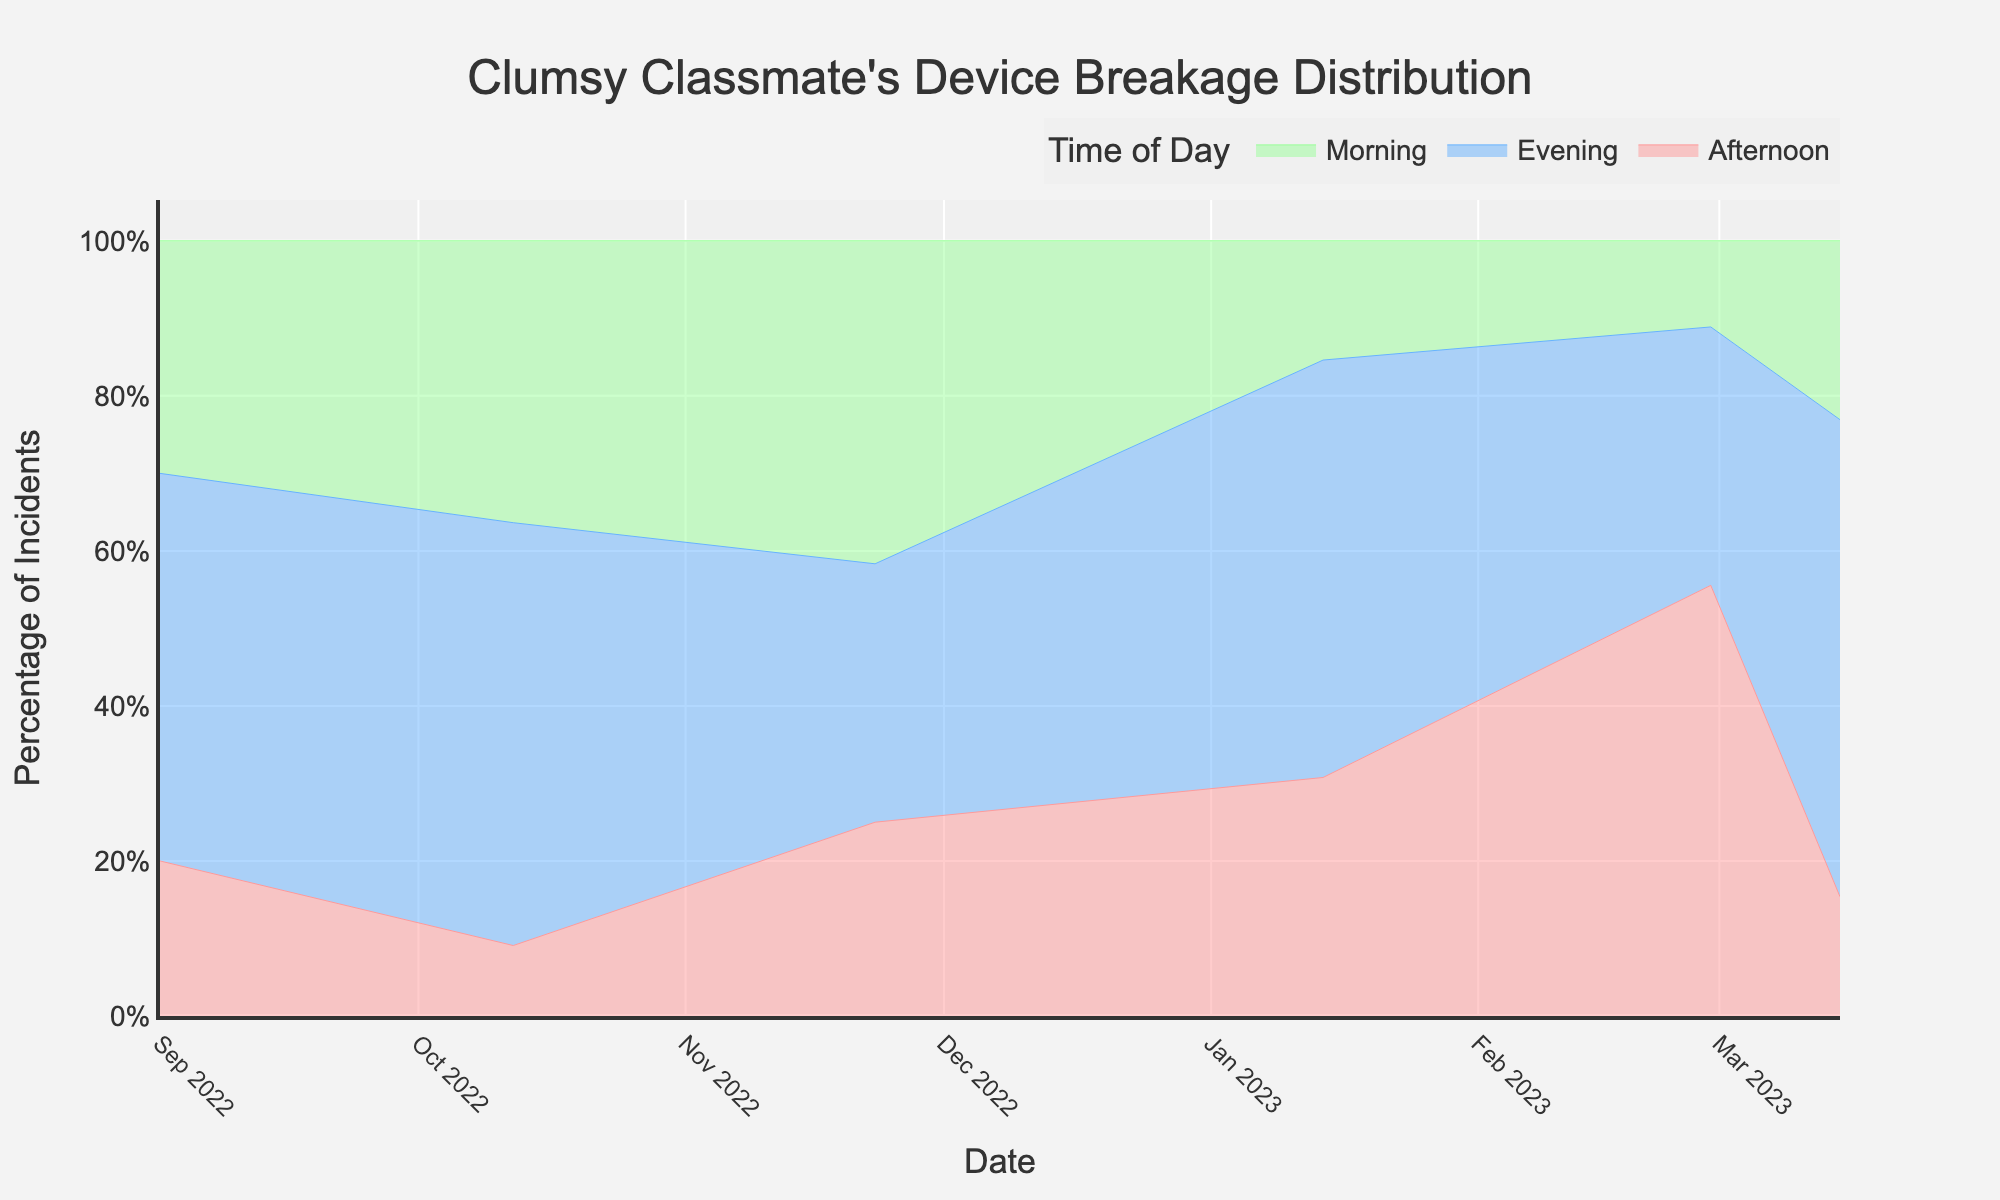What is the title of the chart? The title is located at the top of the chart. It’s phrased as a sentence describing the chart's content.
Answer: Clumsy Classmate's Device Breakage Distribution Which time of day had the highest percentage of incidents in March? Reviewing the chart for March, the evening has the highest area coverage, indicating the highest percentage.
Answer: Evening How did the percentage of morning incidents change from September to March? Look at the morning segment in September and compare it to March. The height of the morning segment decreased.
Answer: Decreased Which time of day has the most consistent percentage of incidents throughout the academic year? Consistency can be observed by the smoothness and lack of significant variation in the stack's height across all dates. The afternoon segment appears the most stable.
Answer: Afternoon Are there any months where the morning incidents surpassed both afternoon and evening incidents? Examine each month's morning segment compared to the remaining time of day segments. No such month is found.
Answer: No What is the overall trend for evening incidents throughout the academic year? By tracing the evening segment line across the academic year, you note an overall increase.
Answer: Increasing In which month was the percentage of afternoon incidents the highest? By checking each month's afternoon segment, January stands out with the highest proportion.
Answer: January What is the combined percentage of morning and afternoon incidents in February? Sum the heights of morning and afternoon segments in February; morning is significantly low; afternoon is moderate. Visual estimation gives around 35-40%.
Answer: About 40% Comparing November and February, which month had a higher percentage of incidents in the morning? Observing the morning segment for both months, November's segment is taller than February's.
Answer: November What is the fluctuation range for evening incidents over the academic year? Identify the maximum and minimum segments for evening and calculate the difference. The evening segment fluctuates from about 30% to over 60%.
Answer: 30%-60% 